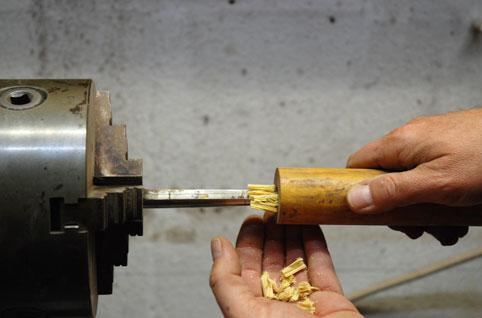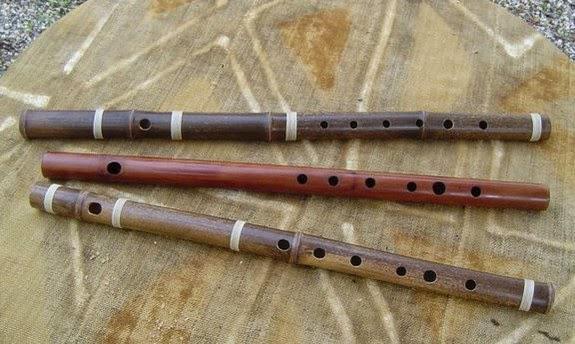The first image is the image on the left, the second image is the image on the right. For the images shown, is this caption "There are at least five futes." true? Answer yes or no. No. 